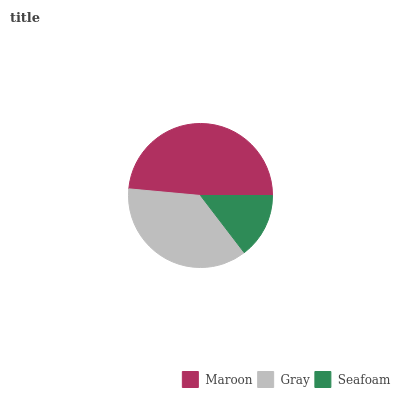Is Seafoam the minimum?
Answer yes or no. Yes. Is Maroon the maximum?
Answer yes or no. Yes. Is Gray the minimum?
Answer yes or no. No. Is Gray the maximum?
Answer yes or no. No. Is Maroon greater than Gray?
Answer yes or no. Yes. Is Gray less than Maroon?
Answer yes or no. Yes. Is Gray greater than Maroon?
Answer yes or no. No. Is Maroon less than Gray?
Answer yes or no. No. Is Gray the high median?
Answer yes or no. Yes. Is Gray the low median?
Answer yes or no. Yes. Is Seafoam the high median?
Answer yes or no. No. Is Maroon the low median?
Answer yes or no. No. 